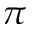Convert formula to latex. <formula><loc_0><loc_0><loc_500><loc_500>\pi</formula> 